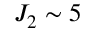<formula> <loc_0><loc_0><loc_500><loc_500>J _ { 2 } \sim 5</formula> 